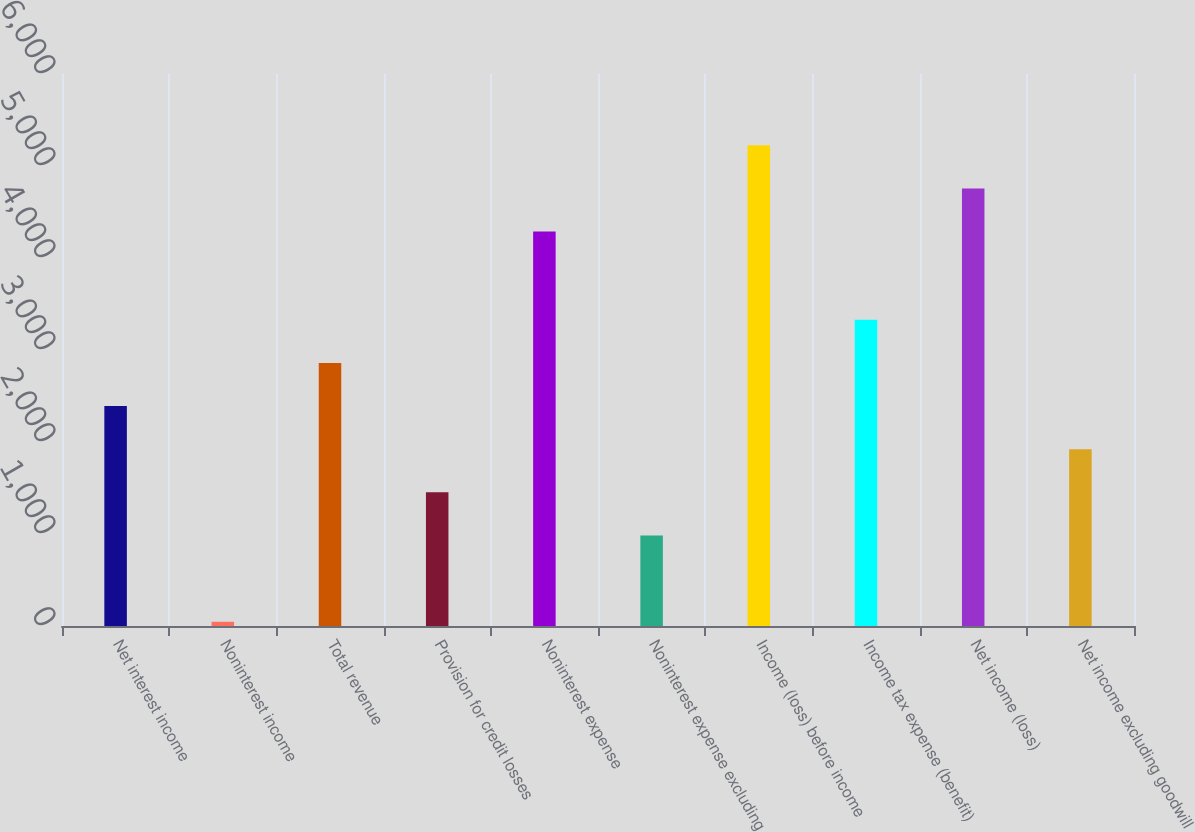<chart> <loc_0><loc_0><loc_500><loc_500><bar_chart><fcel>Net interest income<fcel>Noninterest income<fcel>Total revenue<fcel>Provision for credit losses<fcel>Noninterest expense<fcel>Noninterest expense excluding<fcel>Income (loss) before income<fcel>Income tax expense (benefit)<fcel>Net income (loss)<fcel>Net income excluding goodwill<nl><fcel>2391<fcel>46<fcel>2860<fcel>1453<fcel>4287<fcel>984<fcel>5225<fcel>3329<fcel>4756<fcel>1922<nl></chart> 